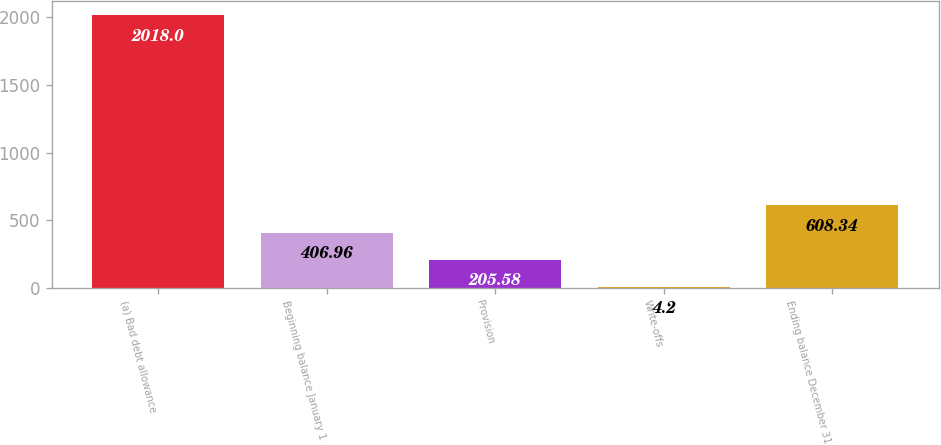Convert chart. <chart><loc_0><loc_0><loc_500><loc_500><bar_chart><fcel>(a) Bad debt allowance<fcel>Beginning balance January 1<fcel>Provision<fcel>Write-offs<fcel>Ending balance December 31<nl><fcel>2018<fcel>406.96<fcel>205.58<fcel>4.2<fcel>608.34<nl></chart> 